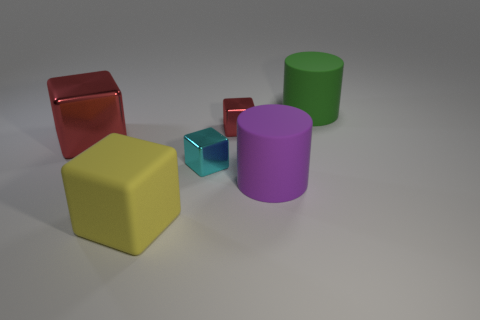Subtract all large yellow cubes. How many cubes are left? 3 Subtract all cylinders. How many objects are left? 4 Subtract all green cylinders. How many cylinders are left? 1 Add 3 small cyan objects. How many objects exist? 9 Subtract all purple rubber things. Subtract all yellow matte objects. How many objects are left? 4 Add 6 large yellow rubber objects. How many large yellow rubber objects are left? 7 Add 4 small blue metal cylinders. How many small blue metal cylinders exist? 4 Subtract 1 cyan cubes. How many objects are left? 5 Subtract 2 blocks. How many blocks are left? 2 Subtract all red cylinders. Subtract all yellow balls. How many cylinders are left? 2 